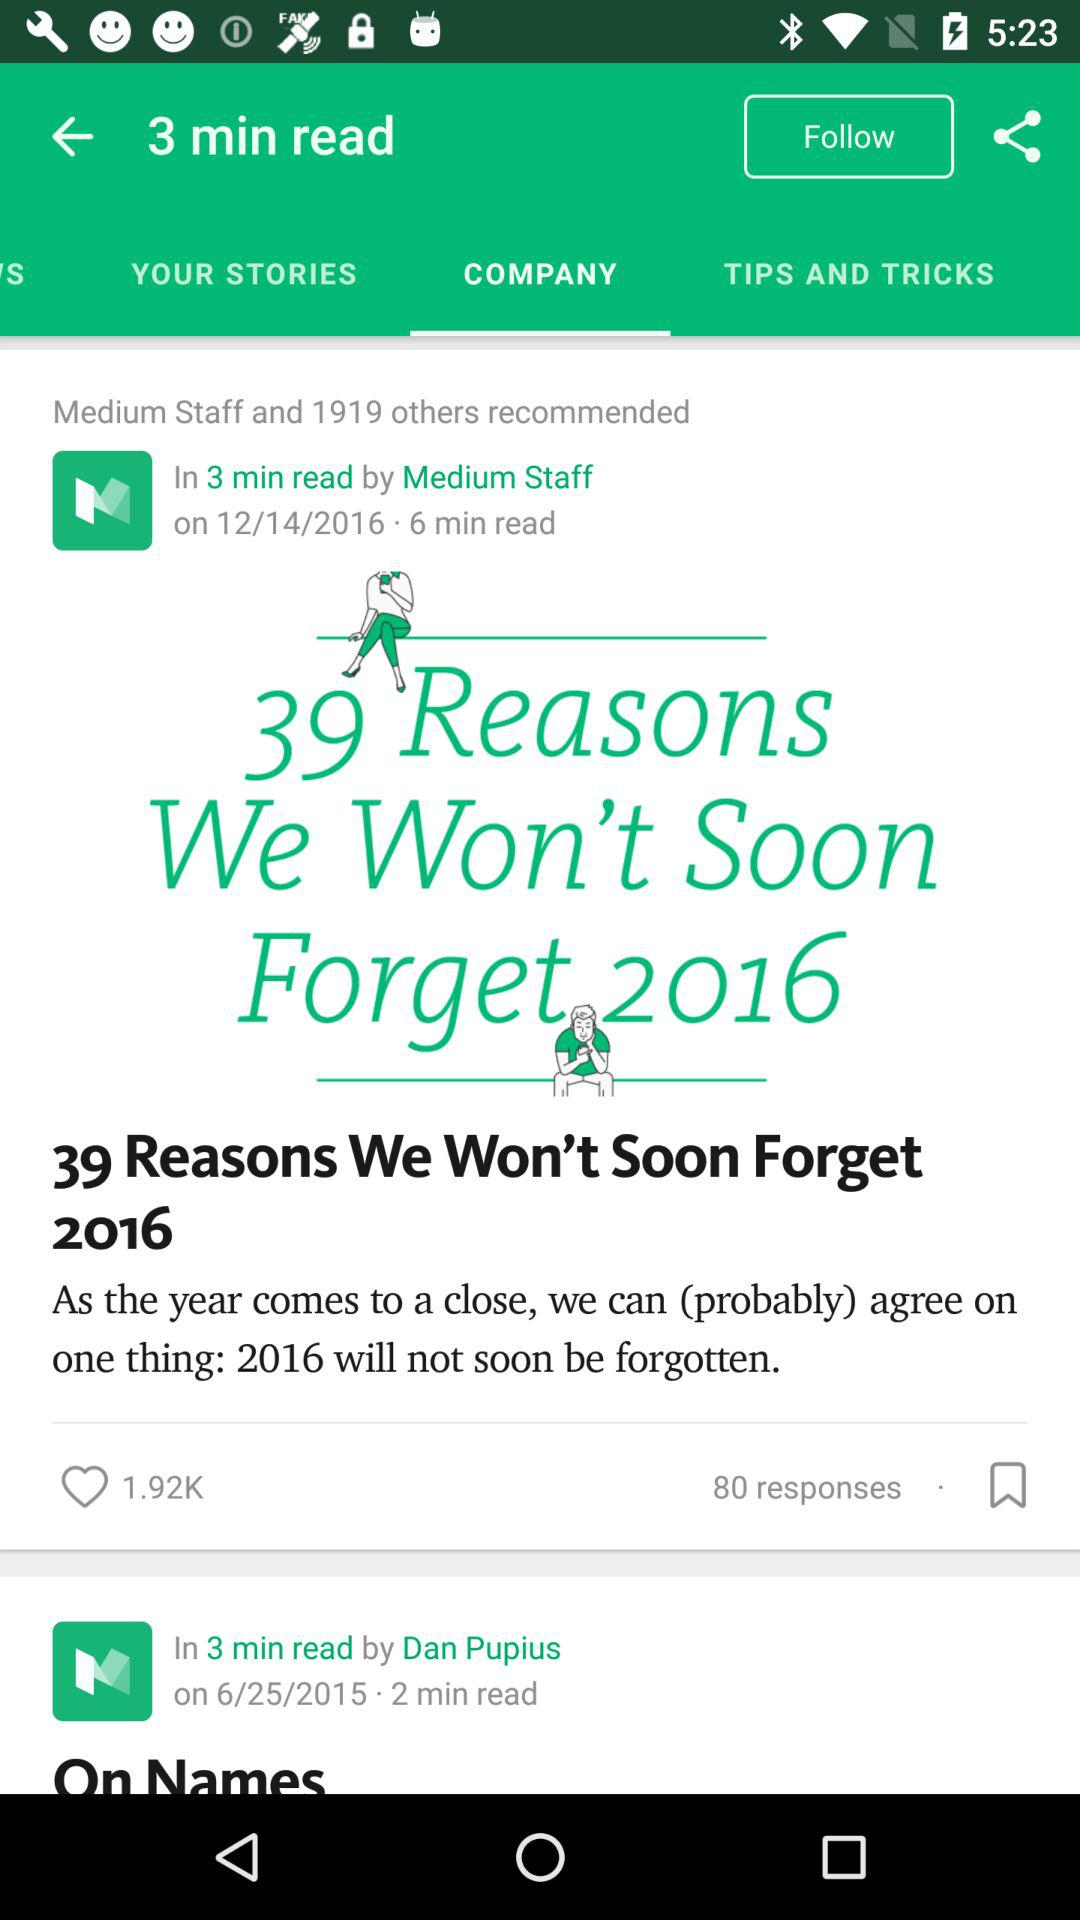How many more people recommended the first story than the second?
Answer the question using a single word or phrase. 1919 